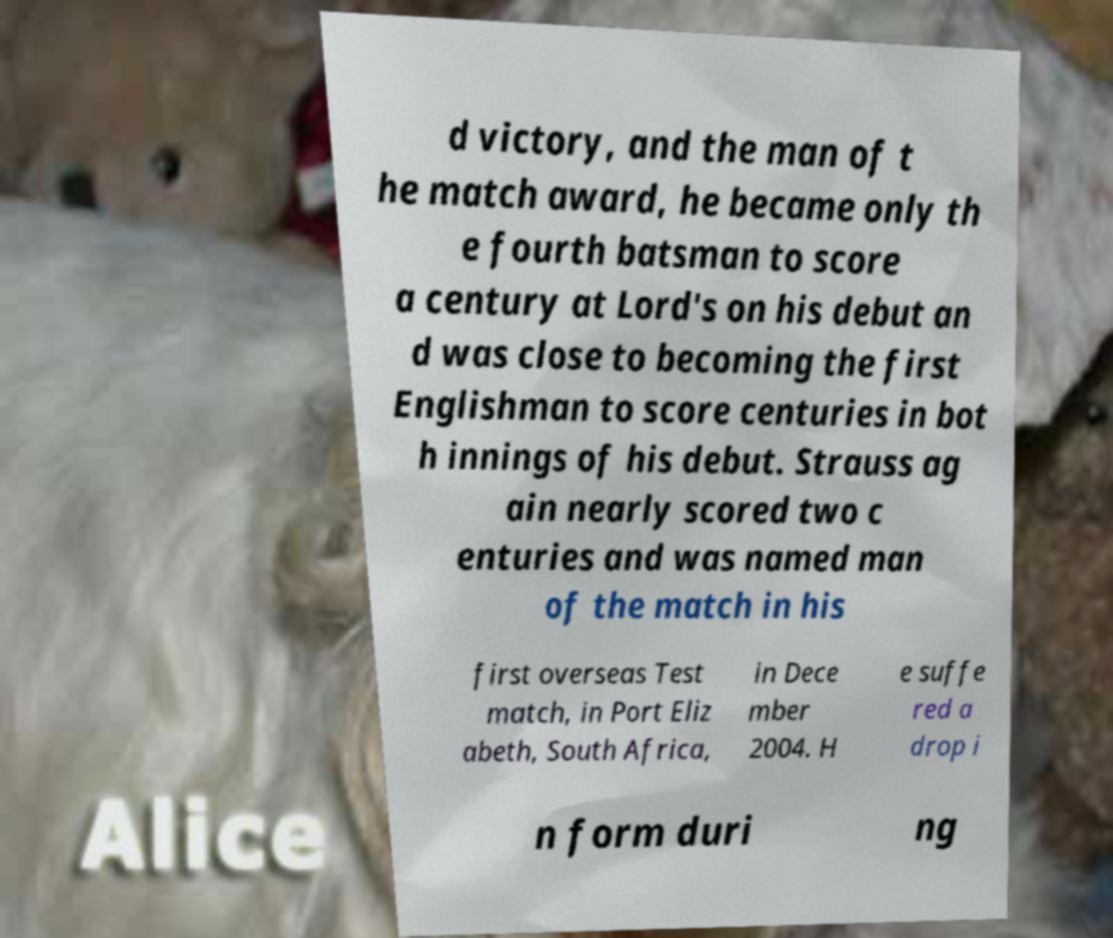For documentation purposes, I need the text within this image transcribed. Could you provide that? d victory, and the man of t he match award, he became only th e fourth batsman to score a century at Lord's on his debut an d was close to becoming the first Englishman to score centuries in bot h innings of his debut. Strauss ag ain nearly scored two c enturies and was named man of the match in his first overseas Test match, in Port Eliz abeth, South Africa, in Dece mber 2004. H e suffe red a drop i n form duri ng 